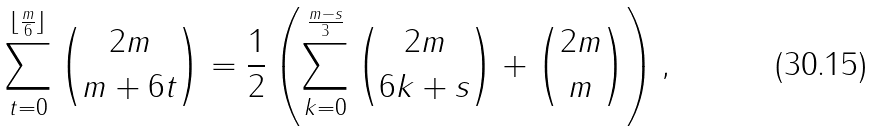<formula> <loc_0><loc_0><loc_500><loc_500>\sum ^ { \lfloor \frac { m } { 6 } \rfloor } _ { t = 0 } \binom { 2 m } { m + 6 t } = \frac { 1 } { 2 } \left ( \sum _ { k = 0 } ^ { \frac { m - s } { 3 } } \binom { 2 m } { 6 k + s } + \binom { 2 m } { m } \right ) ,</formula> 